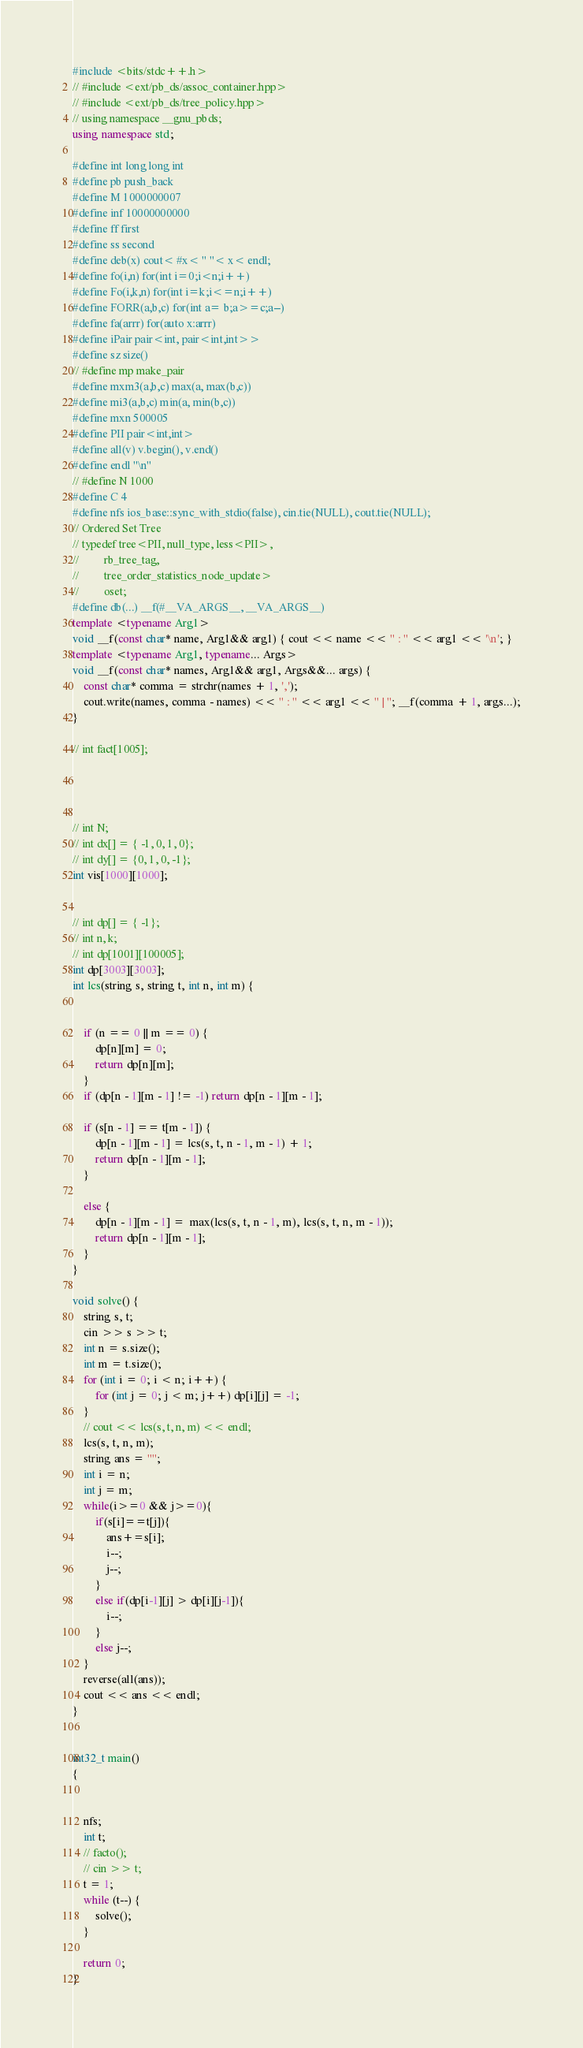Convert code to text. <code><loc_0><loc_0><loc_500><loc_500><_C++_>#include <bits/stdc++.h>
// #include <ext/pb_ds/assoc_container.hpp>
// #include <ext/pb_ds/tree_policy.hpp>
// using namespace __gnu_pbds;
using namespace std;

#define int long long int
#define pb push_back
#define M 1000000007
#define inf 10000000000
#define ff first
#define ss second
#define deb(x) cout< #x< " "< x< endl;
#define fo(i,n) for(int i=0;i<n;i++)
#define Fo(i,k,n) for(int i=k;i<=n;i++)
#define FORR(a,b,c) for(int a= b;a>=c;a--)
#define fa(arrr) for(auto x:arrr)
#define iPair pair<int, pair<int,int>>
#define sz size()
// #define mp make_pair
#define mxm3(a,b,c) max(a, max(b,c))
#define mi3(a,b,c) min(a, min(b,c))
#define mxn 500005
#define PII pair<int,int>
#define all(v) v.begin(), v.end()
#define endl "\n"
// #define N 1000
#define C 4
#define nfs ios_base::sync_with_stdio(false), cin.tie(NULL), cout.tie(NULL);
// Ordered Set Tree
// typedef tree<PII, null_type, less<PII>,
//         rb_tree_tag,
//         tree_order_statistics_node_update>
//         oset;
#define db(...) __f(#__VA_ARGS__, __VA_ARGS__)
template <typename Arg1>
void __f(const char* name, Arg1&& arg1) { cout << name << " : " << arg1 << '\n'; }
template <typename Arg1, typename... Args>
void __f(const char* names, Arg1&& arg1, Args&&... args) {
    const char* comma = strchr(names + 1, ',');
    cout.write(names, comma - names) << " : " << arg1 << " | "; __f(comma + 1, args...);
}

// int fact[1005];




// int N;
// int dx[] = { -1, 0, 1, 0};
// int dy[] = {0, 1, 0, -1};
int vis[1000][1000];


// int dp[] = { -1};
// int n, k;
// int dp[1001][100005];
int dp[3003][3003];
int lcs(string s, string t, int n, int m) {


    if (n == 0 || m == 0) {
        dp[n][m] = 0;
        return dp[n][m];
    }
    if (dp[n - 1][m - 1] != -1) return dp[n - 1][m - 1];

    if (s[n - 1] == t[m - 1]) {
        dp[n - 1][m - 1] = lcs(s, t, n - 1, m - 1) + 1;
        return dp[n - 1][m - 1];
    }

    else {
        dp[n - 1][m - 1] =  max(lcs(s, t, n - 1, m), lcs(s, t, n, m - 1));
        return dp[n - 1][m - 1];
    }
}

void solve() {
    string s, t;
    cin >> s >> t;
    int n = s.size();
    int m = t.size();
    for (int i = 0; i < n; i++) {
        for (int j = 0; j < m; j++) dp[i][j] = -1;
    }
    // cout << lcs(s, t, n, m) << endl;
    lcs(s, t, n, m);
    string ans = "";
    int i = n;
    int j = m;
    while(i>=0 && j>=0){
        if(s[i]==t[j]){
            ans+=s[i];
            i--;
            j--;
        }
        else if(dp[i-1][j] > dp[i][j-1]){
            i--;
        }
        else j--;
    }
    reverse(all(ans));
    cout << ans << endl;
}


int32_t main()
{


    nfs;
    int t;
    // facto();
    // cin >> t;
    t = 1;
    while (t--) {
        solve();
    }

    return 0;
}</code> 